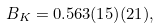Convert formula to latex. <formula><loc_0><loc_0><loc_500><loc_500>B _ { K } = 0 . 5 6 3 ( 1 5 ) ( 2 1 ) ,</formula> 